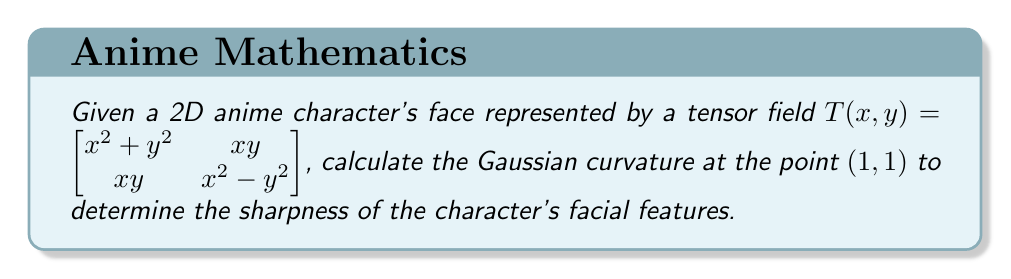What is the answer to this math problem? To calculate the Gaussian curvature of a 2D surface represented by a tensor field, we need to follow these steps:

1. Calculate the first fundamental form coefficients:
   $E = T_{11} = x^2 + y^2$
   $F = T_{12} = T_{21} = xy$
   $G = T_{22} = x^2 - y^2$

2. Calculate the second derivatives of the tensor field components:
   $T_{11,x} = 2x$, $T_{11,y} = 2y$
   $T_{12,x} = y$, $T_{12,y} = x$
   $T_{22,x} = 2x$, $T_{22,y} = -2y$

3. Calculate the second fundamental form coefficients:
   $L = \frac{T_{11,x}G - 2T_{12,x}F + T_{22,x}E}{\sqrt{EG-F^2}}$
   $M = \frac{T_{11,y}G - T_{12,y}F - T_{12,x}F + T_{22,x}E}{\sqrt{EG-F^2}}$
   $N = \frac{T_{11,y}G - 2T_{12,y}F + T_{22,y}E}{\sqrt{EG-F^2}}$

4. Calculate the Gaussian curvature using the formula:
   $K = \frac{LN - M^2}{EG - F^2}$

Now, let's substitute the point $(1,1)$ into our calculations:

1. $E = 1^2 + 1^2 = 2$, $F = 1 \cdot 1 = 1$, $G = 1^2 - 1^2 = 0$

2. At $(1,1)$:
   $T_{11,x} = 2$, $T_{11,y} = 2$
   $T_{12,x} = 1$, $T_{12,y} = 1$
   $T_{22,x} = 2$, $T_{22,y} = -2$

3. $L = \frac{2 \cdot 0 - 2 \cdot 1 \cdot 1 + 2 \cdot 2}{\sqrt{2 \cdot 0 - 1^2}} = \frac{2}{i}$
   $M = \frac{2 \cdot 0 - 1 \cdot 1 - 1 \cdot 1 + 2 \cdot 2}{\sqrt{2 \cdot 0 - 1^2}} = \frac{2}{i}$
   $N = \frac{2 \cdot 0 - 2 \cdot 1 \cdot 1 + (-2) \cdot 2}{\sqrt{2 \cdot 0 - 1^2}} = -\frac{6}{i}$

4. $K = \frac{(\frac{2}{i})(-\frac{6}{i}) - (\frac{2}{i})^2}{2 \cdot 0 - 1^2} = \frac{-12 - 4}{-1} = 16$

Therefore, the Gaussian curvature at the point $(1,1)$ is 16.
Answer: 16 